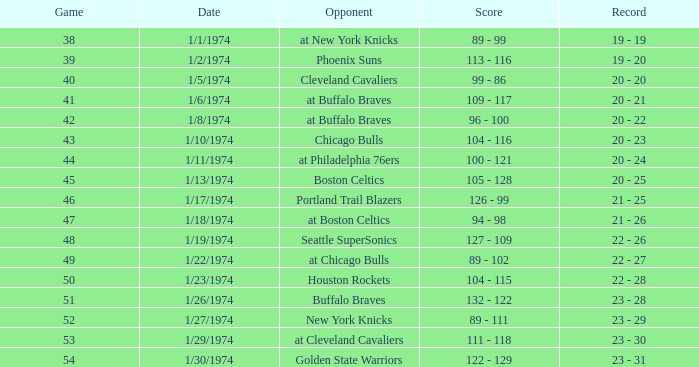What rival participated on 1/13/1974? Boston Celtics. 